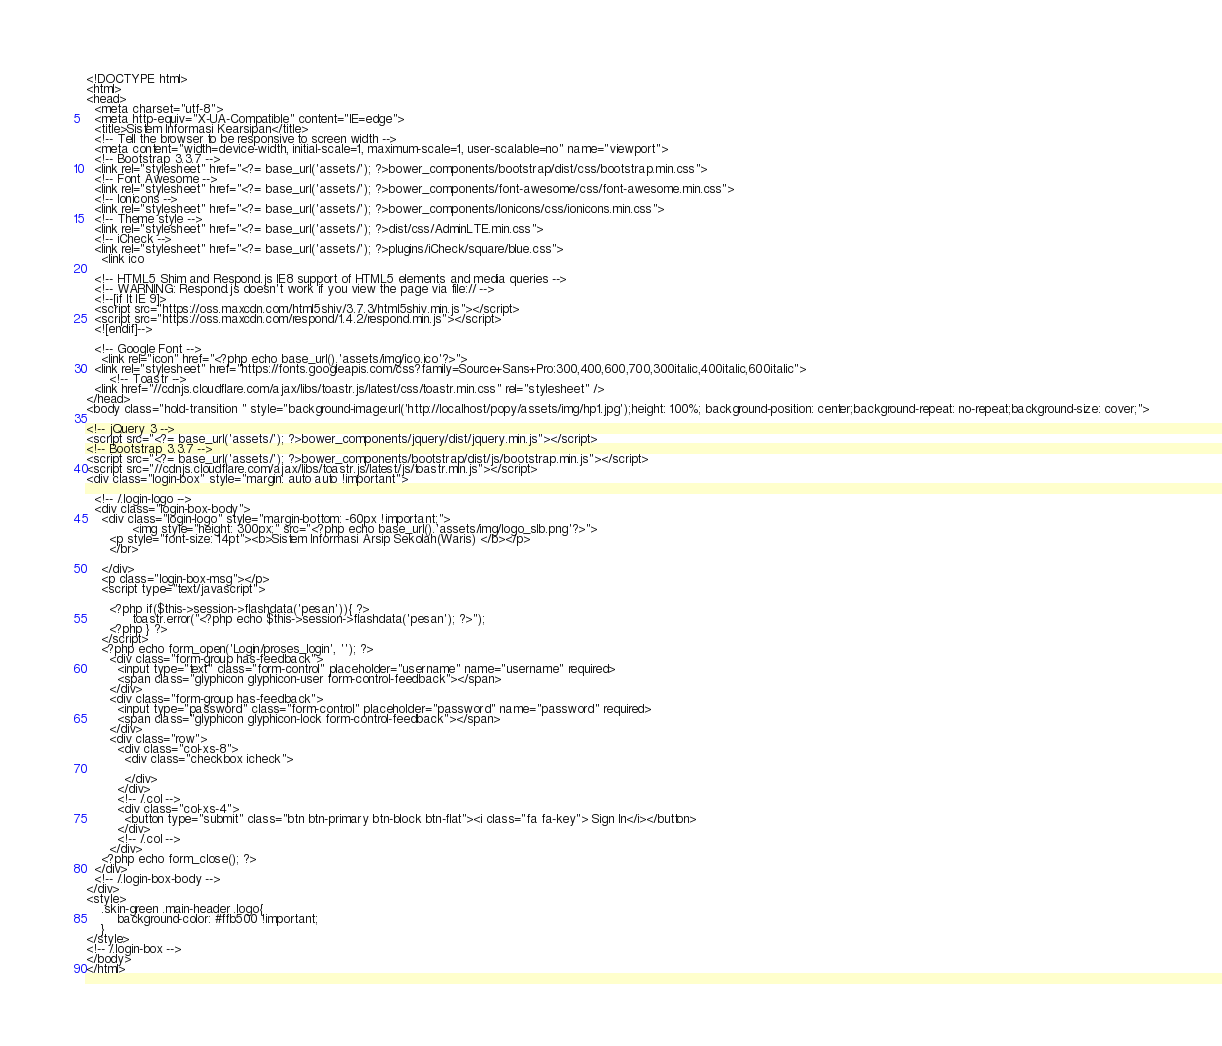Convert code to text. <code><loc_0><loc_0><loc_500><loc_500><_PHP_><!DOCTYPE html>
<html>
<head>
  <meta charset="utf-8">
  <meta http-equiv="X-UA-Compatible" content="IE=edge">
  <title>Sistem Informasi Kearsipan</title>
  <!-- Tell the browser to be responsive to screen width -->
  <meta content="width=device-width, initial-scale=1, maximum-scale=1, user-scalable=no" name="viewport">
  <!-- Bootstrap 3.3.7 -->
  <link rel="stylesheet" href="<?= base_url('assets/'); ?>bower_components/bootstrap/dist/css/bootstrap.min.css">
  <!-- Font Awesome -->
  <link rel="stylesheet" href="<?= base_url('assets/'); ?>bower_components/font-awesome/css/font-awesome.min.css">
  <!-- Ionicons -->
  <link rel="stylesheet" href="<?= base_url('assets/'); ?>bower_components/Ionicons/css/ionicons.min.css">
  <!-- Theme style -->
  <link rel="stylesheet" href="<?= base_url('assets/'); ?>dist/css/AdminLTE.min.css">
  <!-- iCheck -->
  <link rel="stylesheet" href="<?= base_url('assets/'); ?>plugins/iCheck/square/blue.css">
	<link ico

  <!-- HTML5 Shim and Respond.js IE8 support of HTML5 elements and media queries -->
  <!-- WARNING: Respond.js doesn't work if you view the page via file:// -->
  <!--[if lt IE 9]>
  <script src="https://oss.maxcdn.com/html5shiv/3.7.3/html5shiv.min.js"></script>
  <script src="https://oss.maxcdn.com/respond/1.4.2/respond.min.js"></script>
  <![endif]-->

  <!-- Google Font -->
	<link rel="icon" href="<?php echo base_url().'assets/img/ico.ico'?>">
  <link rel="stylesheet" href="https://fonts.googleapis.com/css?family=Source+Sans+Pro:300,400,600,700,300italic,400italic,600italic">
      <!-- Toastr -->
  <link href="//cdnjs.cloudflare.com/ajax/libs/toastr.js/latest/css/toastr.min.css" rel="stylesheet" />
</head>
<body class="hold-transition " style="background-image:url('http://localhost/popy/assets/img/hp1.jpg');height: 100%; background-position: center;background-repeat: no-repeat;background-size: cover;">

<!-- jQuery 3 -->
<script src="<?= base_url('assets/'); ?>bower_components/jquery/dist/jquery.min.js"></script>
<!-- Bootstrap 3.3.7 -->
<script src="<?= base_url('assets/'); ?>bower_components/bootstrap/dist/js/bootstrap.min.js"></script>
<script src="//cdnjs.cloudflare.com/ajax/libs/toastr.js/latest/js/toastr.min.js"></script>
<div class="login-box" style="margin: auto auto !important">

  <!-- /.login-logo -->
  <div class="login-box-body">
    <div class="login-logo" style="margin-bottom: -60px !important;">
			<img style="height: 300px;" src="<?php echo base_url().'assets/img/logo_slb.png'?>">
      <p style="font-size: 14pt"><b>Sistem Informasi Arsip Sekolah(Waris) </b></p>
      </br>
	
    </div>
    <p class="login-box-msg"></p>
    <script type="text/javascript">

      <?php if($this->session->flashdata('pesan')){ ?>
            toastr.error("<?php echo $this->session->flashdata('pesan'); ?>");
      <?php } ?>
    </script>
    <?php echo form_open('Login/proses_login', ''); ?>
      <div class="form-group has-feedback">
        <input type="text" class="form-control" placeholder="username" name="username" required>
        <span class="glyphicon glyphicon-user form-control-feedback"></span>
      </div>
      <div class="form-group has-feedback">
        <input type="password" class="form-control" placeholder="password" name="password" required>
        <span class="glyphicon glyphicon-lock form-control-feedback"></span>
      </div>
      <div class="row">
        <div class="col-xs-8">
          <div class="checkbox icheck">

          </div>
        </div>
        <!-- /.col -->
        <div class="col-xs-4">
          <button type="submit" class="btn btn-primary btn-block btn-flat"><i class="fa fa-key"> Sign In</i></button>
        </div>
        <!-- /.col -->
      </div>
    <?php echo form_close(); ?>
  </div>
  <!-- /.login-box-body -->
</div>
<style>
	.skin-green .main-header .logo{
		background-color: #ffb500 !important;
	}
</style>
<!-- /.login-box -->
</body>
</html>
</code> 